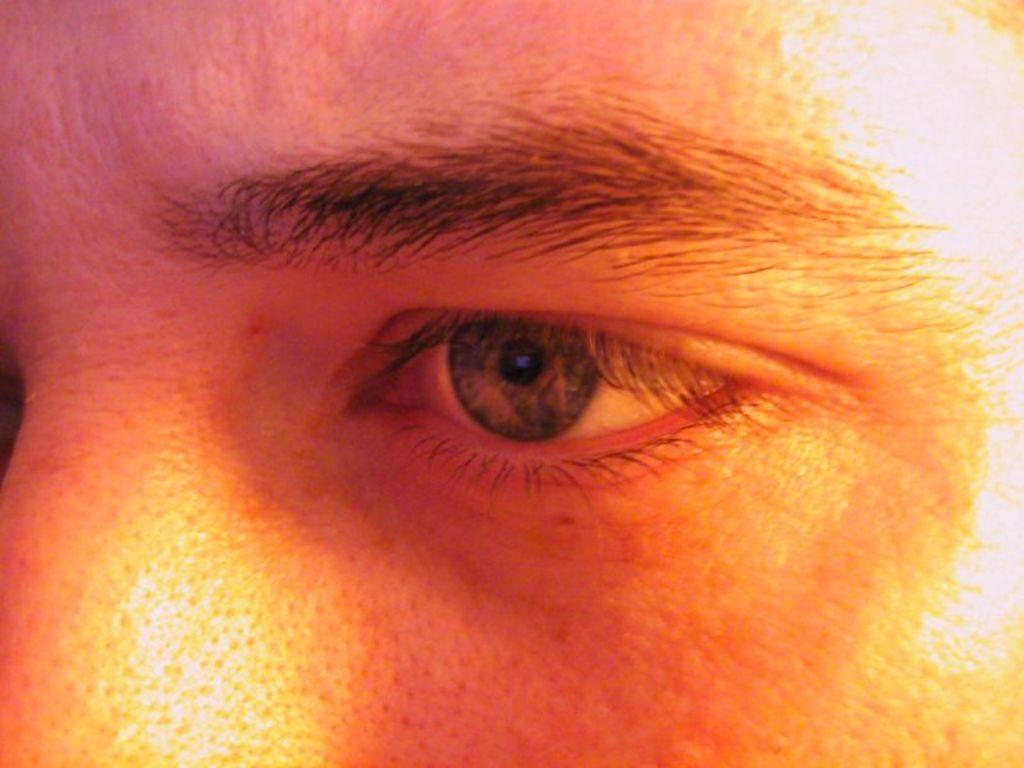How would you summarize this image in a sentence or two? In this image we can see a person. 